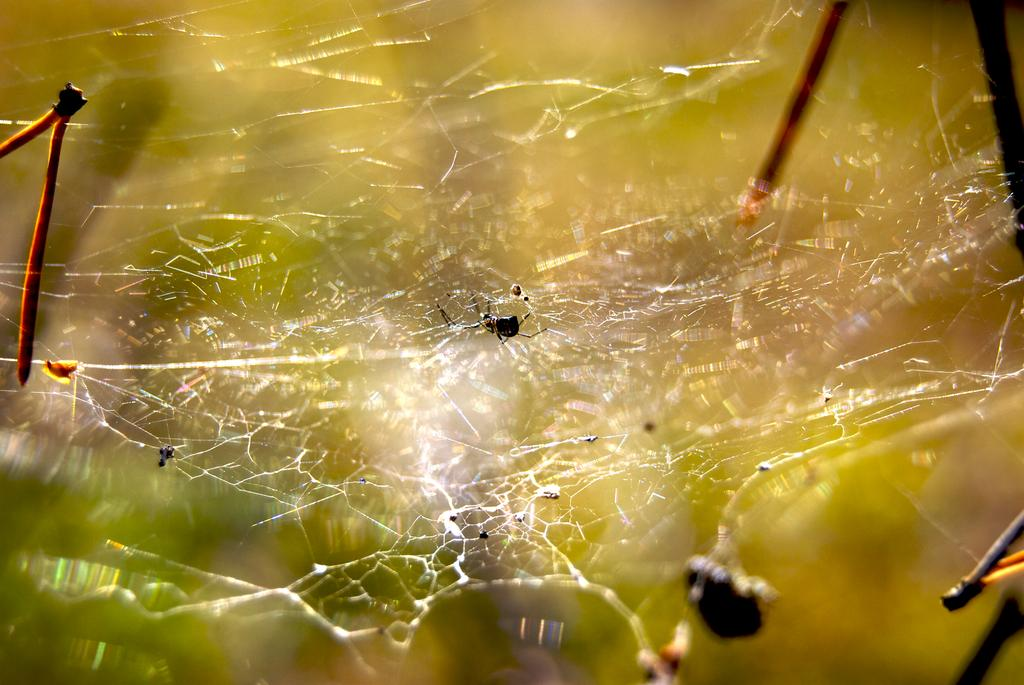What type of creatures can be seen in the image? There are insects in the image. Where are the insects located? The insects are on a web. Can you describe the background of the image? The background of the image is blurred. What is present on the left side of the image? There are wooden sticks on the left side of the image. What type of waves can be seen in the image? There are no waves present in the image. What system is responsible for the insects' behavior in the image? The image does not provide information about a system responsible for the insects' behavior. 